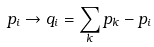<formula> <loc_0><loc_0><loc_500><loc_500>p _ { i } \to q _ { i } = \sum _ { k } p _ { k } - p _ { i }</formula> 